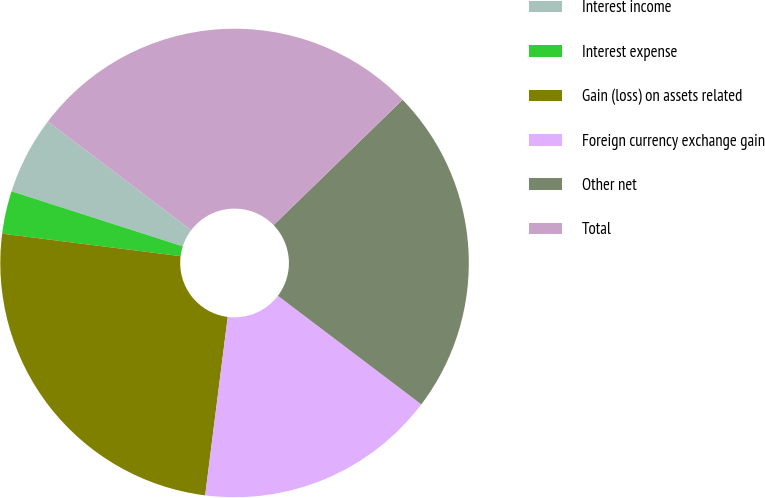<chart> <loc_0><loc_0><loc_500><loc_500><pie_chart><fcel>Interest income<fcel>Interest expense<fcel>Gain (loss) on assets related<fcel>Foreign currency exchange gain<fcel>Other net<fcel>Total<nl><fcel>5.37%<fcel>2.95%<fcel>25.0%<fcel>16.69%<fcel>22.58%<fcel>27.42%<nl></chart> 